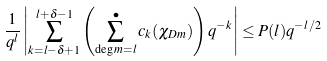<formula> <loc_0><loc_0><loc_500><loc_500>\frac { 1 } { q ^ { l } } \left | \sum _ { k = l - \delta + 1 } ^ { l + \delta - 1 } \left ( \sum _ { \deg m = l } ^ { \bullet } c _ { k } ( \chi _ { D m } ) \right ) q ^ { - k } \right | \leq P ( l ) q ^ { - l / 2 }</formula> 